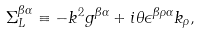Convert formula to latex. <formula><loc_0><loc_0><loc_500><loc_500>\Sigma _ { L } ^ { \beta \alpha } \equiv - k ^ { 2 } g ^ { \beta \alpha } + i \theta \epsilon ^ { \beta \rho \alpha } k _ { \rho } ,</formula> 